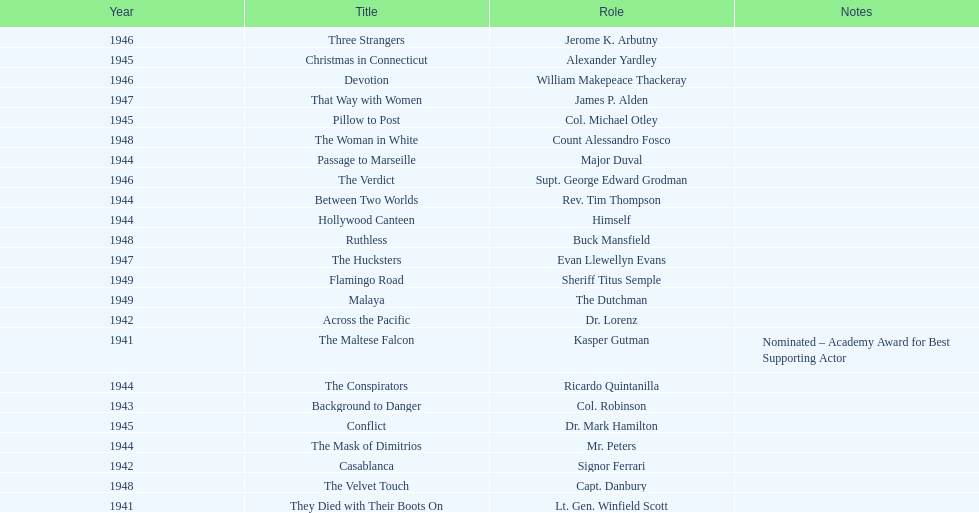What movies did greenstreet act for in 1946? Three Strangers, Devotion, The Verdict. 